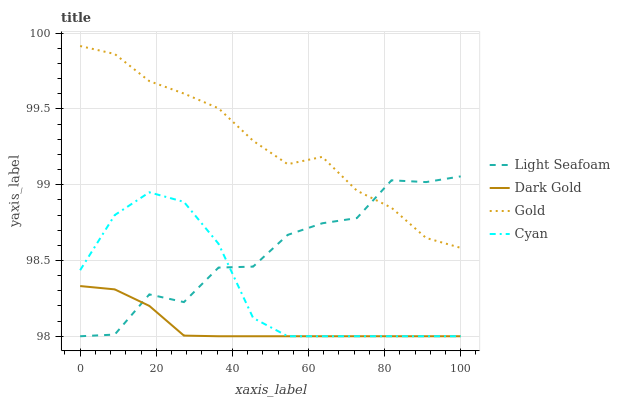Does Dark Gold have the minimum area under the curve?
Answer yes or no. Yes. Does Gold have the maximum area under the curve?
Answer yes or no. Yes. Does Light Seafoam have the minimum area under the curve?
Answer yes or no. No. Does Light Seafoam have the maximum area under the curve?
Answer yes or no. No. Is Dark Gold the smoothest?
Answer yes or no. Yes. Is Light Seafoam the roughest?
Answer yes or no. Yes. Is Gold the smoothest?
Answer yes or no. No. Is Gold the roughest?
Answer yes or no. No. Does Gold have the lowest value?
Answer yes or no. No. Does Gold have the highest value?
Answer yes or no. Yes. Does Light Seafoam have the highest value?
Answer yes or no. No. Is Cyan less than Gold?
Answer yes or no. Yes. Is Gold greater than Dark Gold?
Answer yes or no. Yes. Does Light Seafoam intersect Cyan?
Answer yes or no. Yes. Is Light Seafoam less than Cyan?
Answer yes or no. No. Is Light Seafoam greater than Cyan?
Answer yes or no. No. Does Cyan intersect Gold?
Answer yes or no. No. 